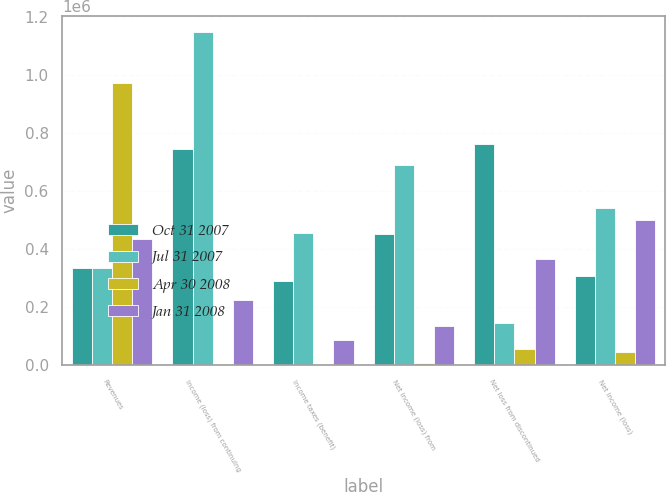<chart> <loc_0><loc_0><loc_500><loc_500><stacked_bar_chart><ecel><fcel>Revenues<fcel>Income (loss) from continuing<fcel>Income taxes (benefit)<fcel>Net income (loss) from<fcel>Net loss from discontinued<fcel>Net income (loss)<nl><fcel>Oct 31 2007<fcel>337406<fcel>745221<fcel>290745<fcel>454476<fcel>763123<fcel>308647<nl><fcel>Jul 31 2007<fcel>337406<fcel>1.14842e+06<fcel>457298<fcel>691120<fcel>147558<fcel>543562<nl><fcel>Apr 30 2008<fcel>972611<fcel>4119<fcel>5165<fcel>9284<fcel>56642<fcel>47358<nl><fcel>Jan 31 2008<fcel>434824<fcel>223736<fcel>87631<fcel>136105<fcel>366166<fcel>502271<nl></chart> 